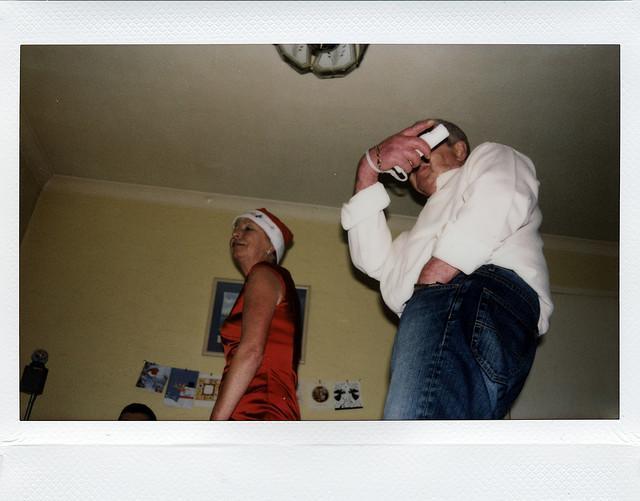How many people are there?
Give a very brief answer. 2. How many giraffes are there?
Give a very brief answer. 0. 